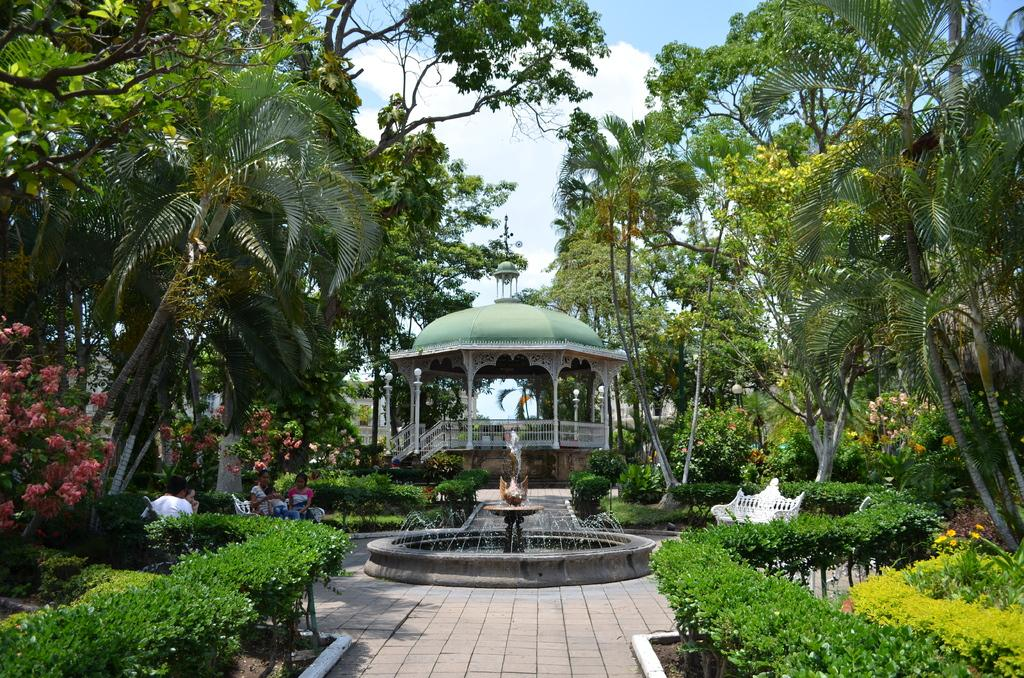What type of living organisms can be seen in the image? Plants and trees are visible in the image. What can be seen in the image besides plants and trees? There is water, benches, people, a fountain, stairs, a fence, and the sky visible in the image. Can you describe the location of the fountain in the image? The fountain is in the middle of the image. What architectural feature is present in the image? There are stairs in the image. What is the color of the sky in the image? The sky is visible in the image, but the color is not mentioned in the facts. What type of loaf is being carried by the person in the image? There is no loaf present in the image. What is the name of the person in the image? The facts provided do not mention any names. Is there a carriage visible in the image? There is no carriage present in the image. 